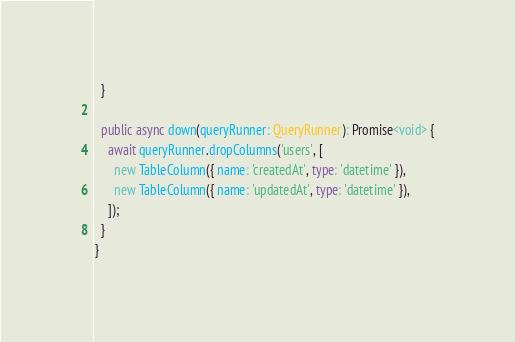<code> <loc_0><loc_0><loc_500><loc_500><_TypeScript_>  }

  public async down(queryRunner: QueryRunner): Promise<void> {
    await queryRunner.dropColumns('users', [
      new TableColumn({ name: 'createdAt', type: 'datetime' }),
      new TableColumn({ name: 'updatedAt', type: 'datetime' }),
    ]);
  }
}
</code> 